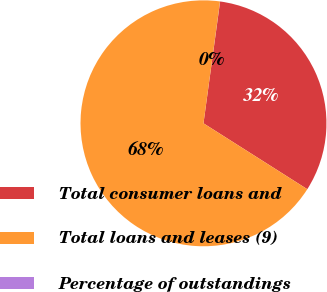<chart> <loc_0><loc_0><loc_500><loc_500><pie_chart><fcel>Total consumer loans and<fcel>Total loans and leases (9)<fcel>Percentage of outstandings<nl><fcel>31.84%<fcel>68.15%<fcel>0.01%<nl></chart> 